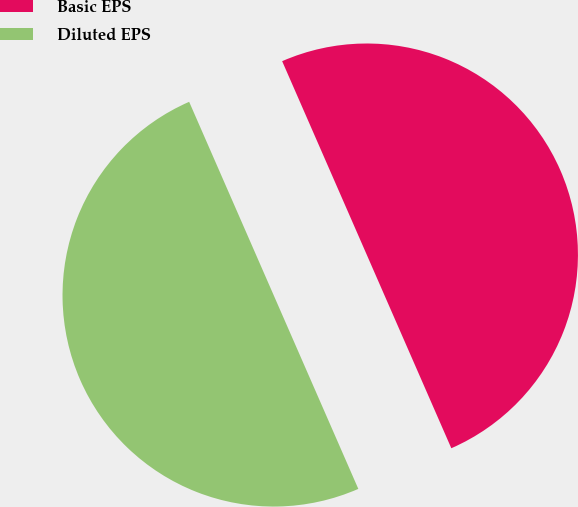Convert chart to OTSL. <chart><loc_0><loc_0><loc_500><loc_500><pie_chart><fcel>Basic EPS<fcel>Diluted EPS<nl><fcel>50.0%<fcel>50.0%<nl></chart> 